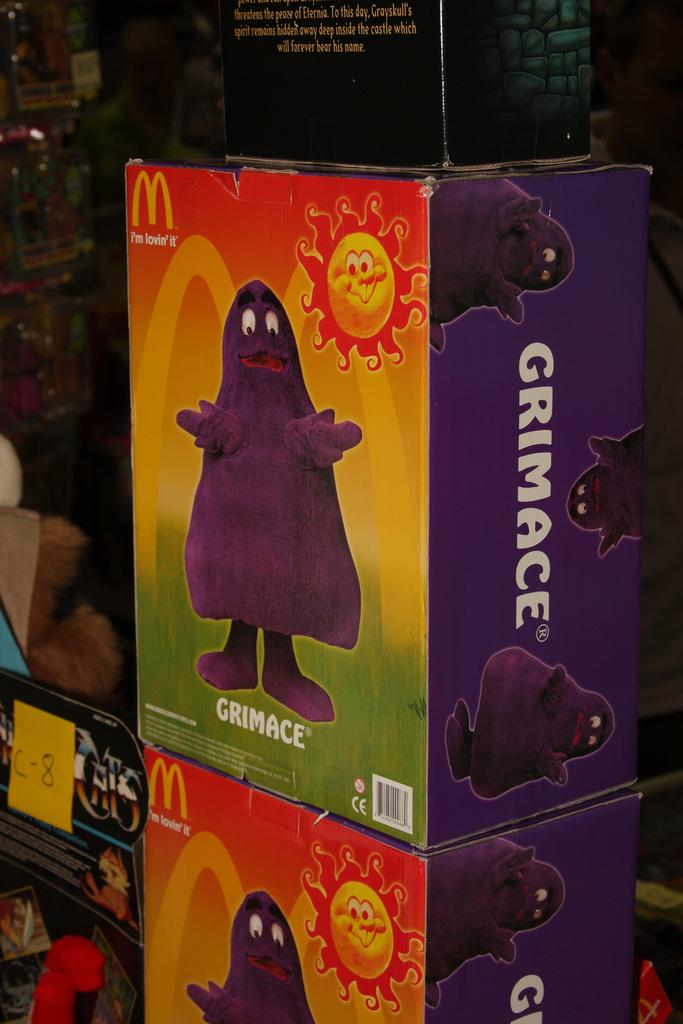<image>
Write a terse but informative summary of the picture. A cardboard box with a purple cartoon character on it labeled GRIMACE 